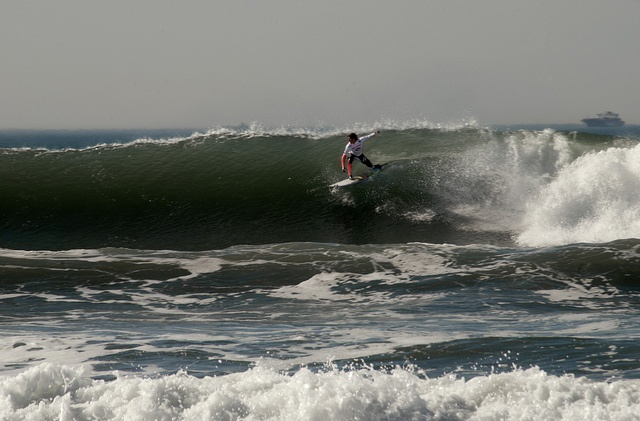Describe the objects in this image and their specific colors. I can see people in darkgray, black, gray, and maroon tones, boat in darkgray, gray, and blue tones, and surfboard in darkgray, black, and gray tones in this image. 